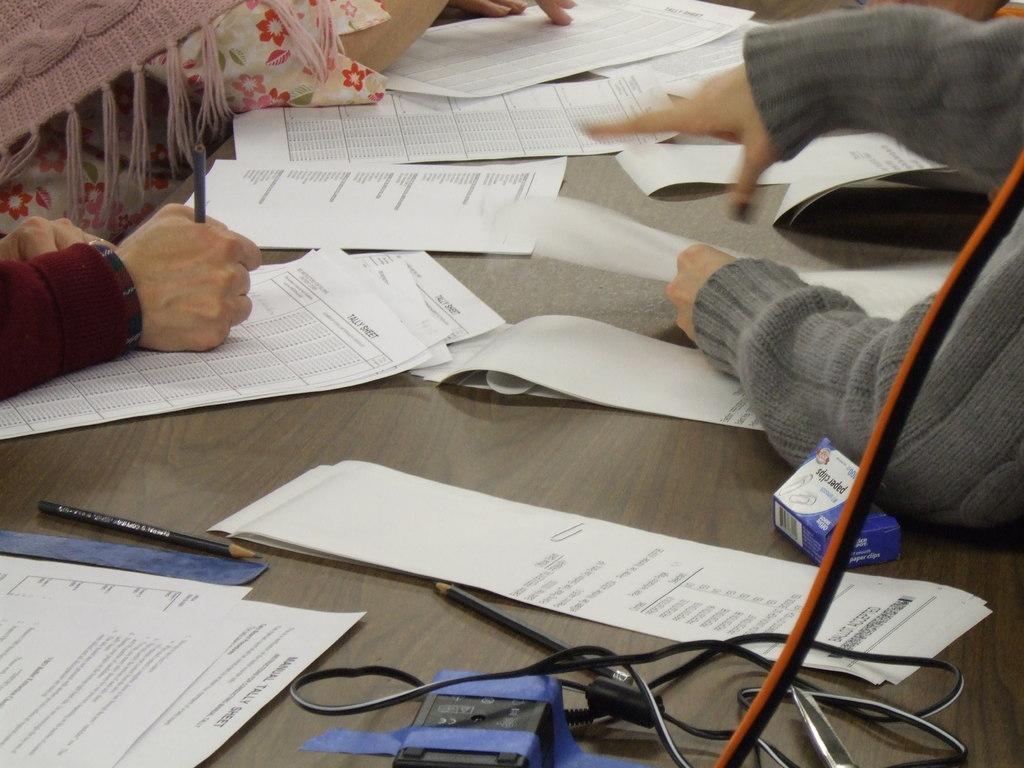In one or two sentences, can you explain what this image depicts? In this image I can see a table which is black and brown in color and on it I can see few wires, few papers, few pencils and I can see hands of few persons who are holding papers and pens in their hands. 